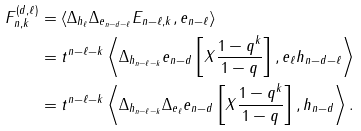<formula> <loc_0><loc_0><loc_500><loc_500>F _ { n , k } ^ { ( d , \ell ) } & = \langle \Delta _ { h _ { \ell } } \Delta _ { e _ { n - d - \ell } } E _ { n - \ell , k } , e _ { n - \ell } \rangle \\ & = t ^ { n - \ell - k } \left \langle \Delta _ { h _ { n - \ell - k } } e _ { n - d } \left [ X \frac { 1 - q ^ { k } } { 1 - q } \right ] , e _ { \ell } h _ { n - d - \ell } \right \rangle \\ & = t ^ { n - \ell - k } \left \langle \Delta _ { h _ { n - \ell - k } } \Delta _ { e _ { \ell } } e _ { n - d } \left [ X \frac { 1 - q ^ { k } } { 1 - q } \right ] , h _ { n - d } \right \rangle .</formula> 